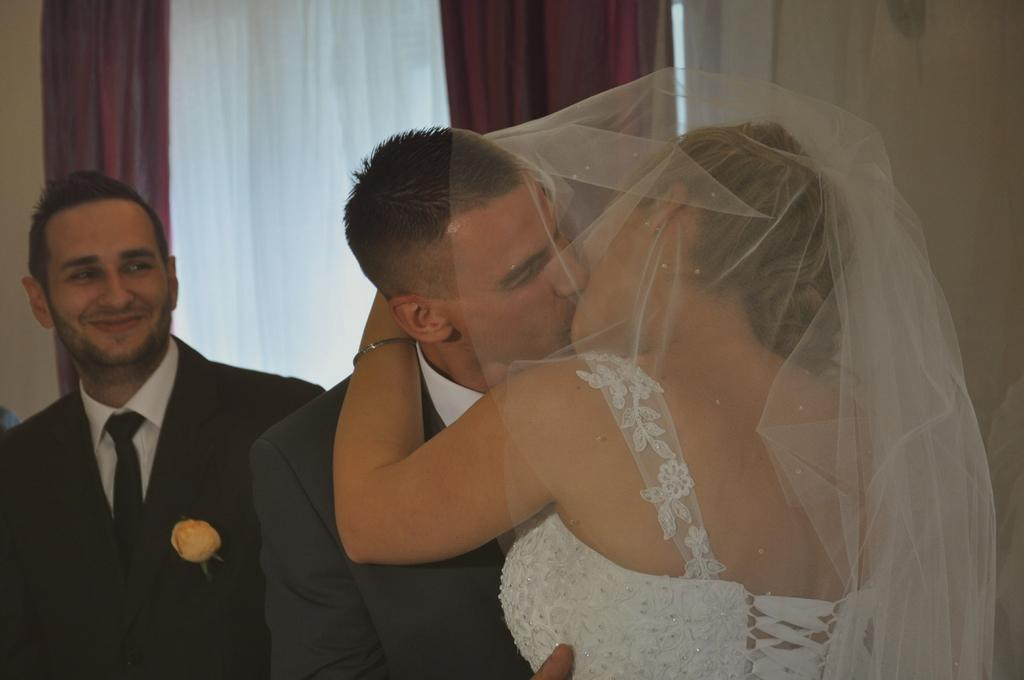What are the two people in the image doing? There is a man and a woman are kissing in the image. Can you describe the clothing of the man in the image? The man is wearing a blazer and tie in the image. What is the man's facial expression? The man is smiling in the image. What can be seen in the background of the image? There are curtains visible in the background of the image. What type of needle is the scarecrow using to sew in the image? There is no scarecrow or needle present in the image; it features a man and a woman kissing, with a man wearing a blazer and tie, who is smiling, and curtains visible in the background. 